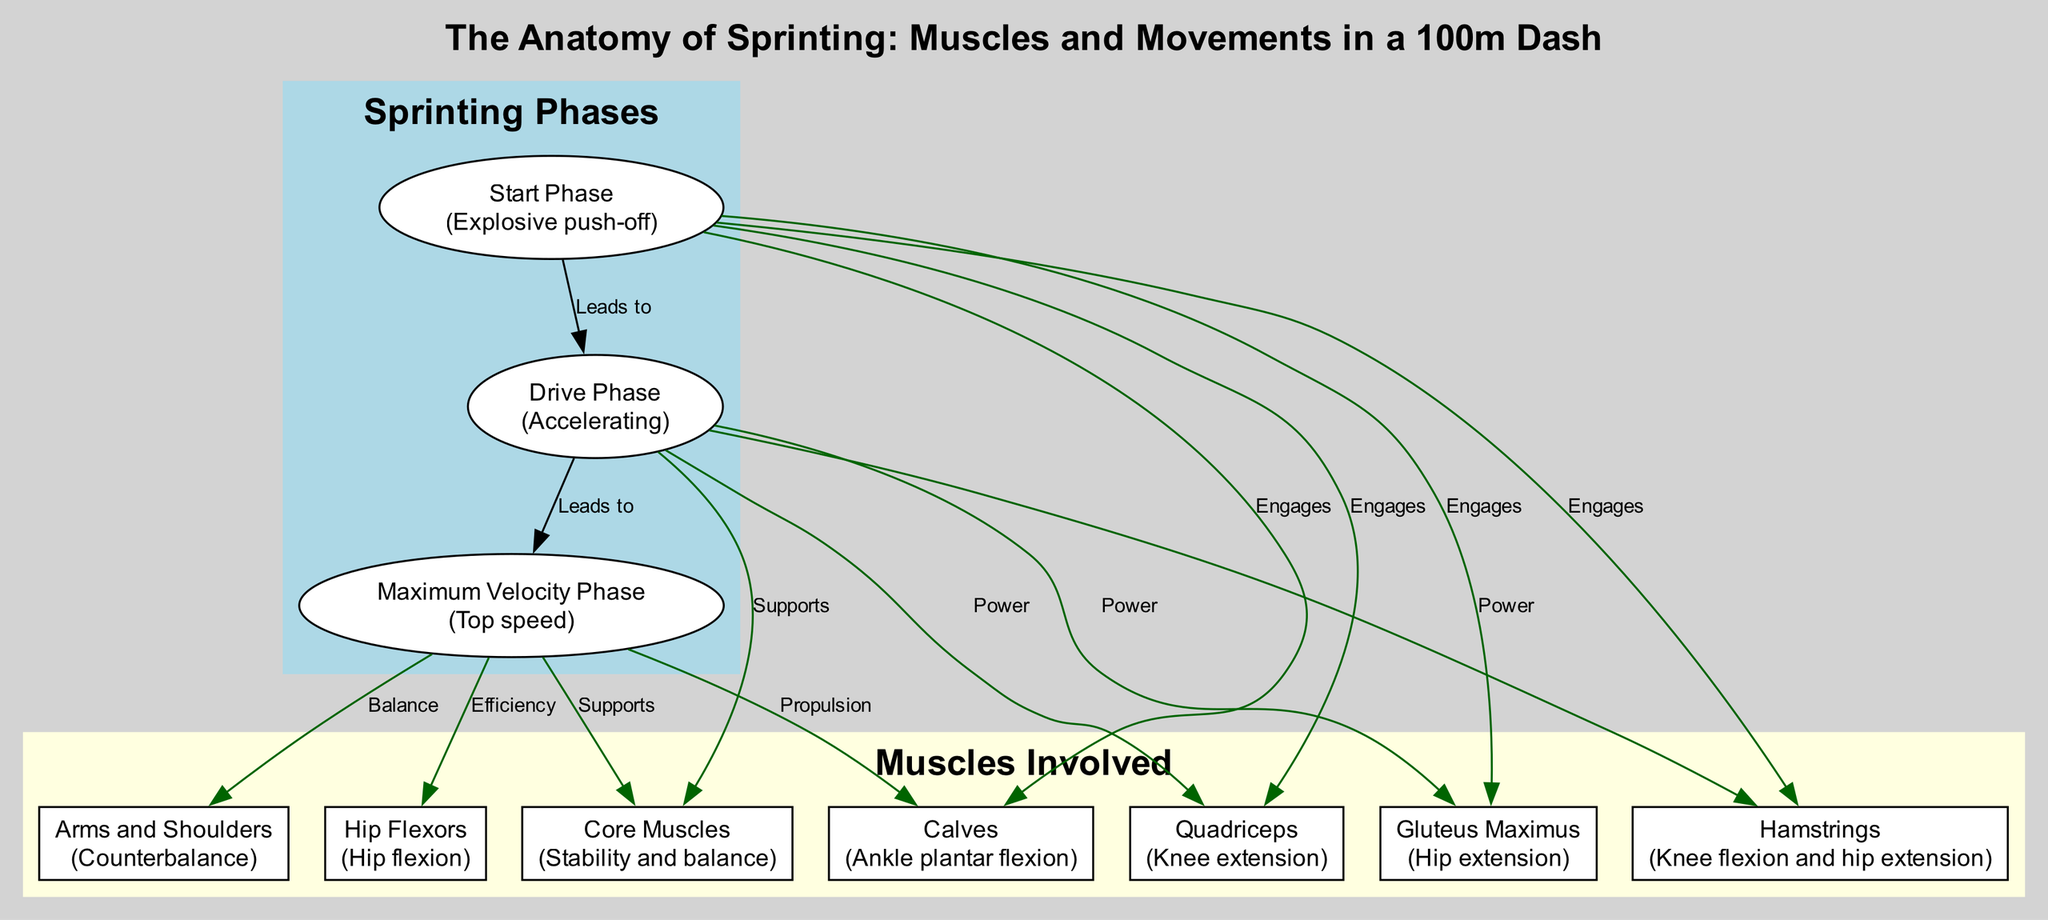What is the first phase of sprinting? The diagram indicates that the first phase of sprinting is labeled "Start Phase," which is described as "Explosive push-off."
Answer: Start Phase How many muscles are engaged during the Start Phase? The Start Phase engages four muscles, as indicated by the edges connecting the "Start Phase" node to the nodes representing Hamstrings, Quadriceps, Gluteus Maximus, and Calves.
Answer: Four Which phase leads to Maximum Velocity Phase? The diagram shows an edge labeled "Leads to" from the "Drive Phase" node to the "Maximum Velocity Phase" node, indicating that the Drive Phase leads to Maximum Velocity Phase.
Answer: Drive Phase What muscles are primarily involved in supporting the Maximum Velocity Phase? According to the diagram, the muscles identified as supporting the Maximum Velocity Phase are Core Muscles and Arms and Shoulders, evidenced by the edges leading from the Maximum Velocity Phase to these nodes.
Answer: Core Muscles and Arms and Shoulders What action do the Hip Flexors assist with? An edge from the Maximum Velocity Phase to the Hip Flexors indicates that they are connected through the label "Efficiency," suggesting that Hip Flexors assist with an action during this phase. The description specifies that they are involved in "Hip flexion."
Answer: Hip flexion Which muscle is responsible for knee flexion and hip extension? The diagram specifies that the Hamstrings are responsible for "Knee flexion and hip extension," as detailed in the description of the node representing Hamstrings.
Answer: Hamstrings What do the Calves provide during the Maximum Velocity Phase? The diagram connects the Calves to the Maximum Velocity Phase with an edge labeled "Propulsion," and the description clarifies that their function is "Ankle plantar flexion," indicating that they aid in propulsion.
Answer: Propulsion What describes the relationship between the Drive Phase and Power-related muscles? The diagram shows that three muscles (Hamstrings, Quadriceps, and Gluteus Maximus) are connected to the Drive Phase with edges labeled "Power," specifying that these muscles provide power during this phase.
Answer: Three muscles How many phases are depicted in the diagram? The diagram displays three phases of sprinting: Start Phase, Drive Phase, and Maximum Velocity Phase, as seen in the cluster labeled "Sprinting Phases."
Answer: Three 